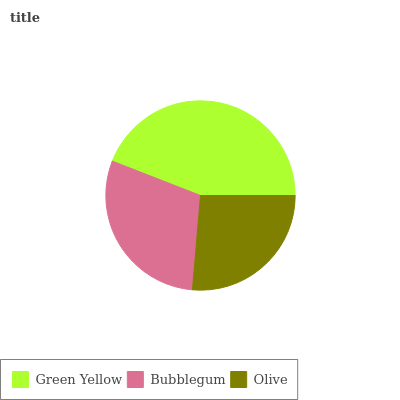Is Olive the minimum?
Answer yes or no. Yes. Is Green Yellow the maximum?
Answer yes or no. Yes. Is Bubblegum the minimum?
Answer yes or no. No. Is Bubblegum the maximum?
Answer yes or no. No. Is Green Yellow greater than Bubblegum?
Answer yes or no. Yes. Is Bubblegum less than Green Yellow?
Answer yes or no. Yes. Is Bubblegum greater than Green Yellow?
Answer yes or no. No. Is Green Yellow less than Bubblegum?
Answer yes or no. No. Is Bubblegum the high median?
Answer yes or no. Yes. Is Bubblegum the low median?
Answer yes or no. Yes. Is Olive the high median?
Answer yes or no. No. Is Green Yellow the low median?
Answer yes or no. No. 